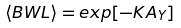Convert formula to latex. <formula><loc_0><loc_0><loc_500><loc_500>\langle B W L \rangle = e x p [ - K A _ { Y } ]</formula> 